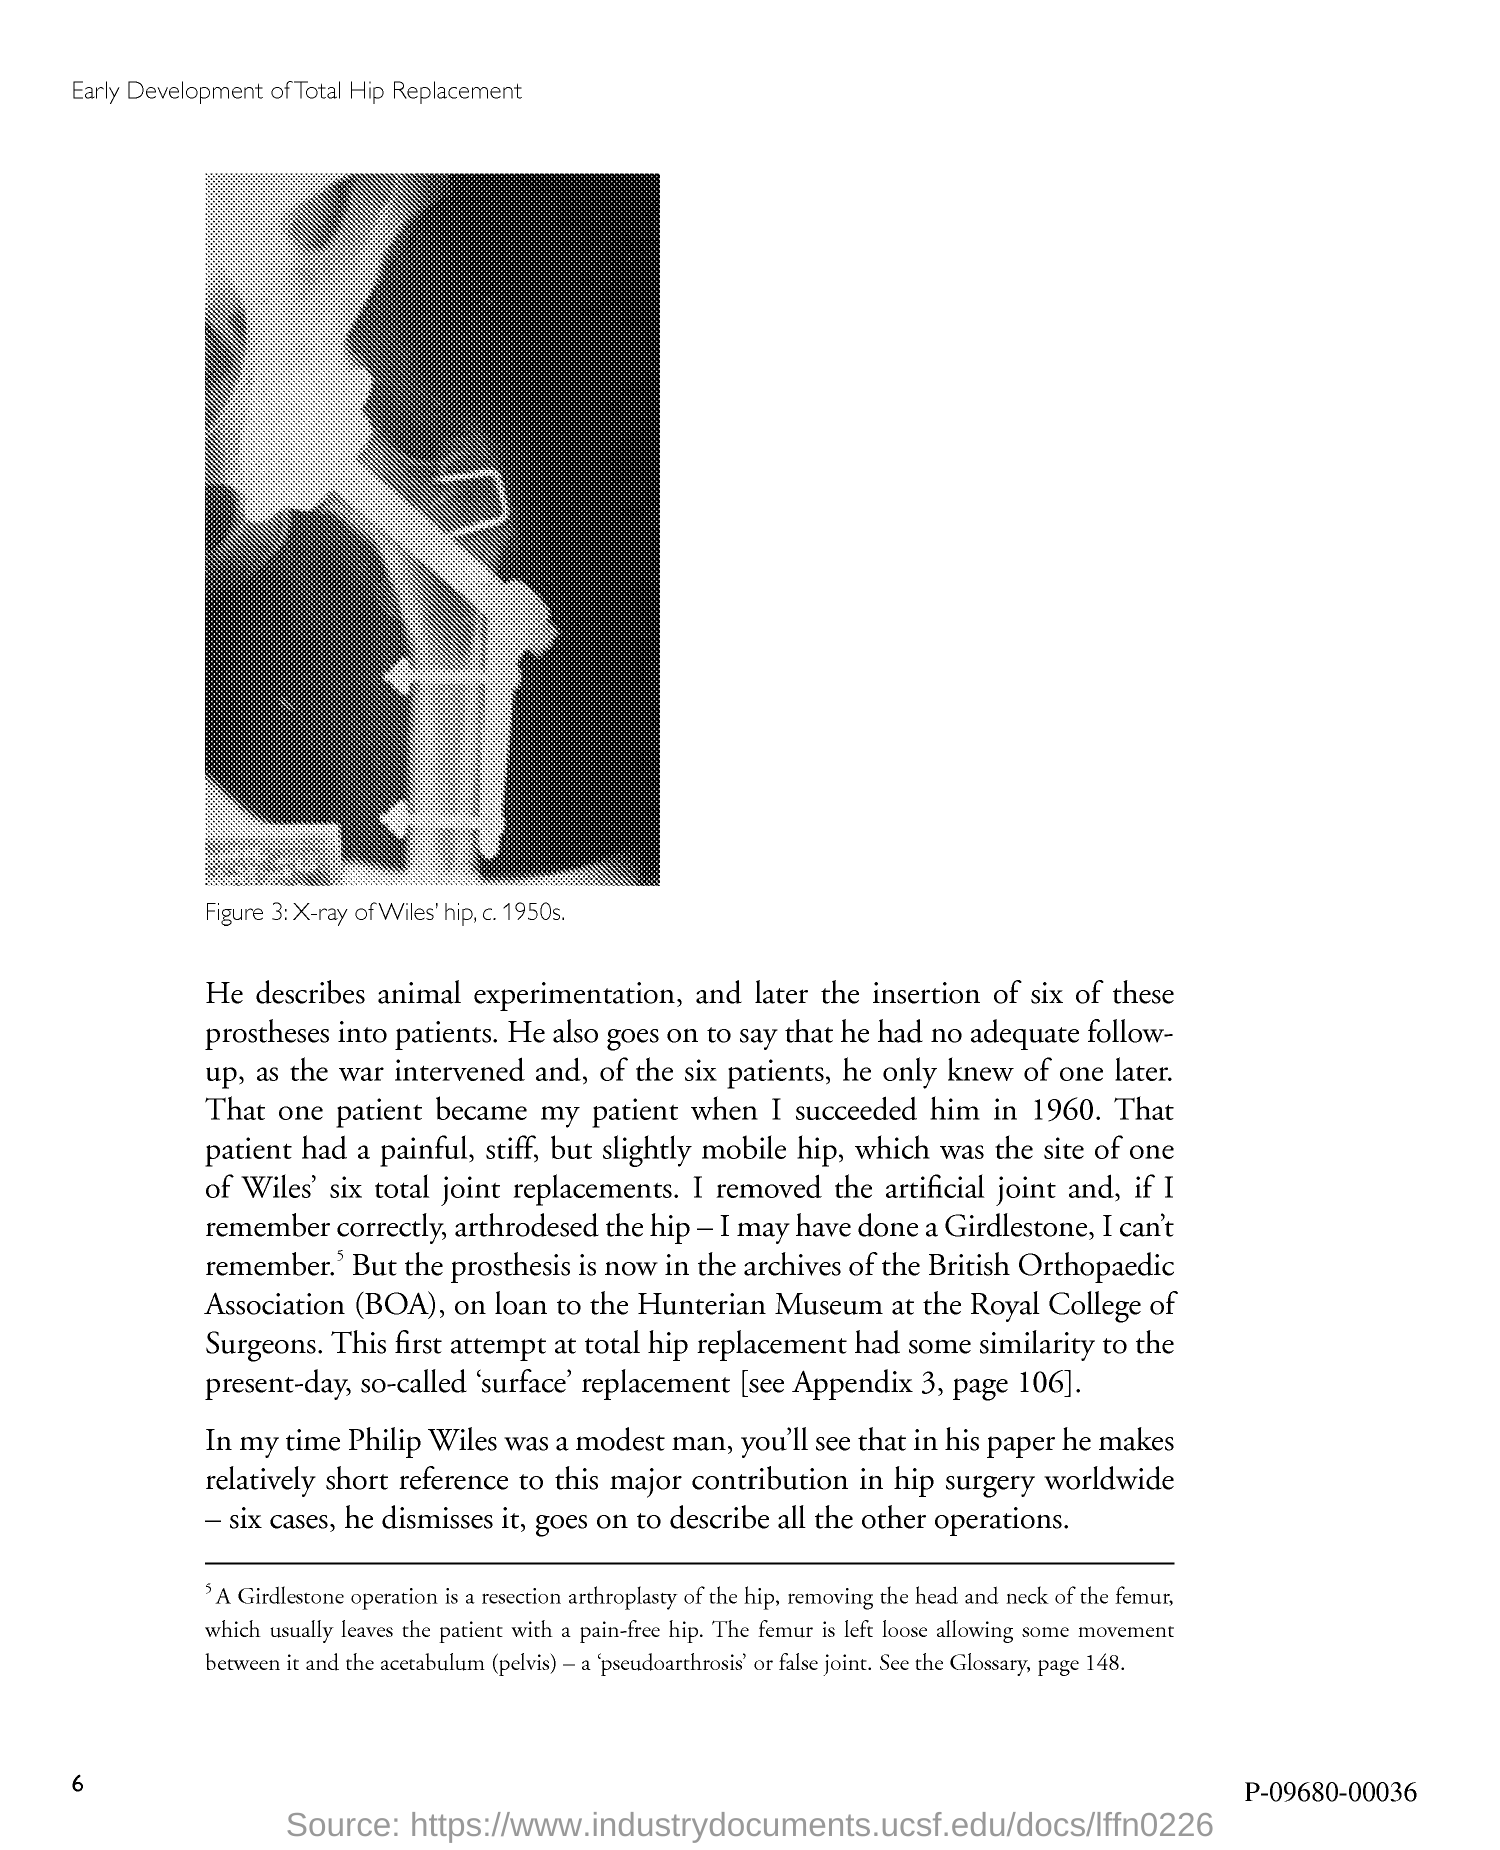Give some essential details in this illustration. The number at the bottom left of the page is 6. 